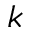<formula> <loc_0><loc_0><loc_500><loc_500>_ { k }</formula> 